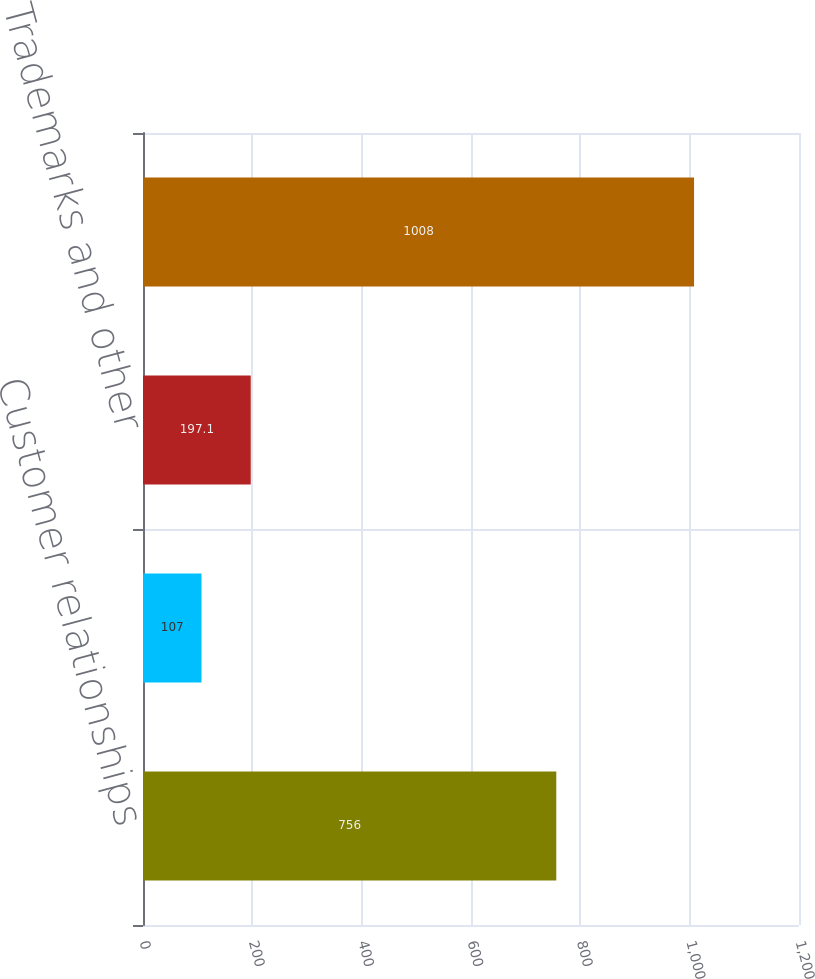Convert chart. <chart><loc_0><loc_0><loc_500><loc_500><bar_chart><fcel>Customer relationships<fcel>Technology<fcel>Trademarks and other<fcel>Total<nl><fcel>756<fcel>107<fcel>197.1<fcel>1008<nl></chart> 